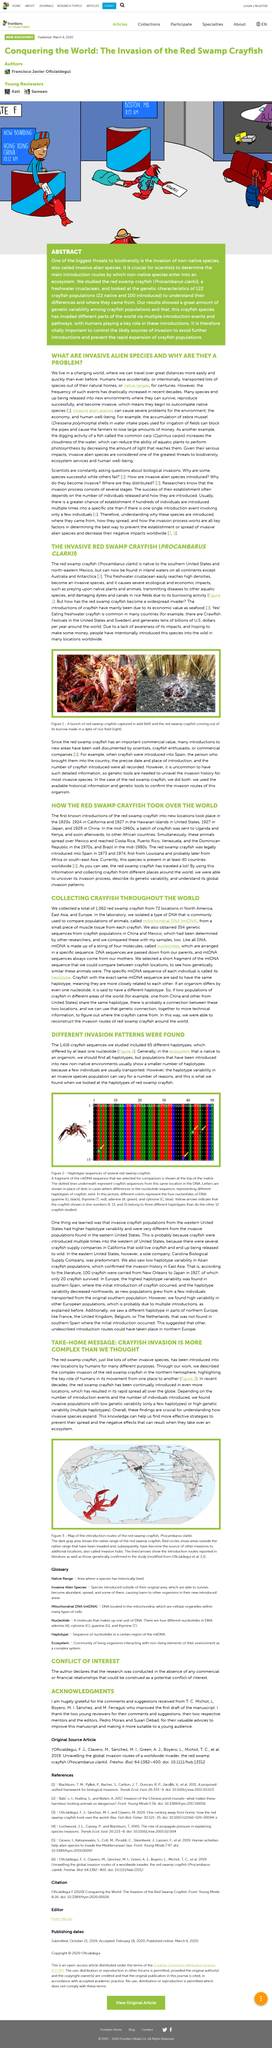Highlight a few significant elements in this photo. In a study conducted in the Western United States, crayfish were found to have a higher level of haplotype variation compared to other areas. Scientists are consistently inquiring about biological invasions. The scientific name of the carp is Cyprinus Carpio. Invasive alien species are a significant problem that require immediate attention and action. These species are non-native to an ecosystem and can rapidly spread and outcompete native species for resources, leading to significant ecological and economic impacts. The name of the title is "Invasive Alien Species: Understanding and Managing the Problem. In this research project, a total of 1416 crayfish sequences were studied. 